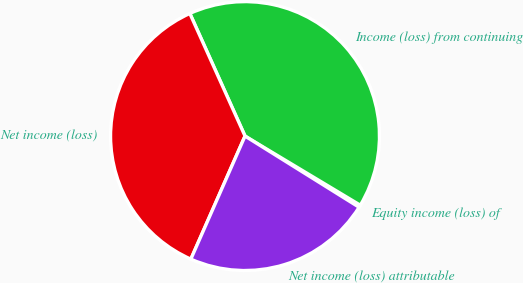Convert chart to OTSL. <chart><loc_0><loc_0><loc_500><loc_500><pie_chart><fcel>Equity income (loss) of<fcel>Income (loss) from continuing<fcel>Net income (loss)<fcel>Net income (loss) attributable<nl><fcel>0.28%<fcel>40.33%<fcel>36.67%<fcel>22.72%<nl></chart> 